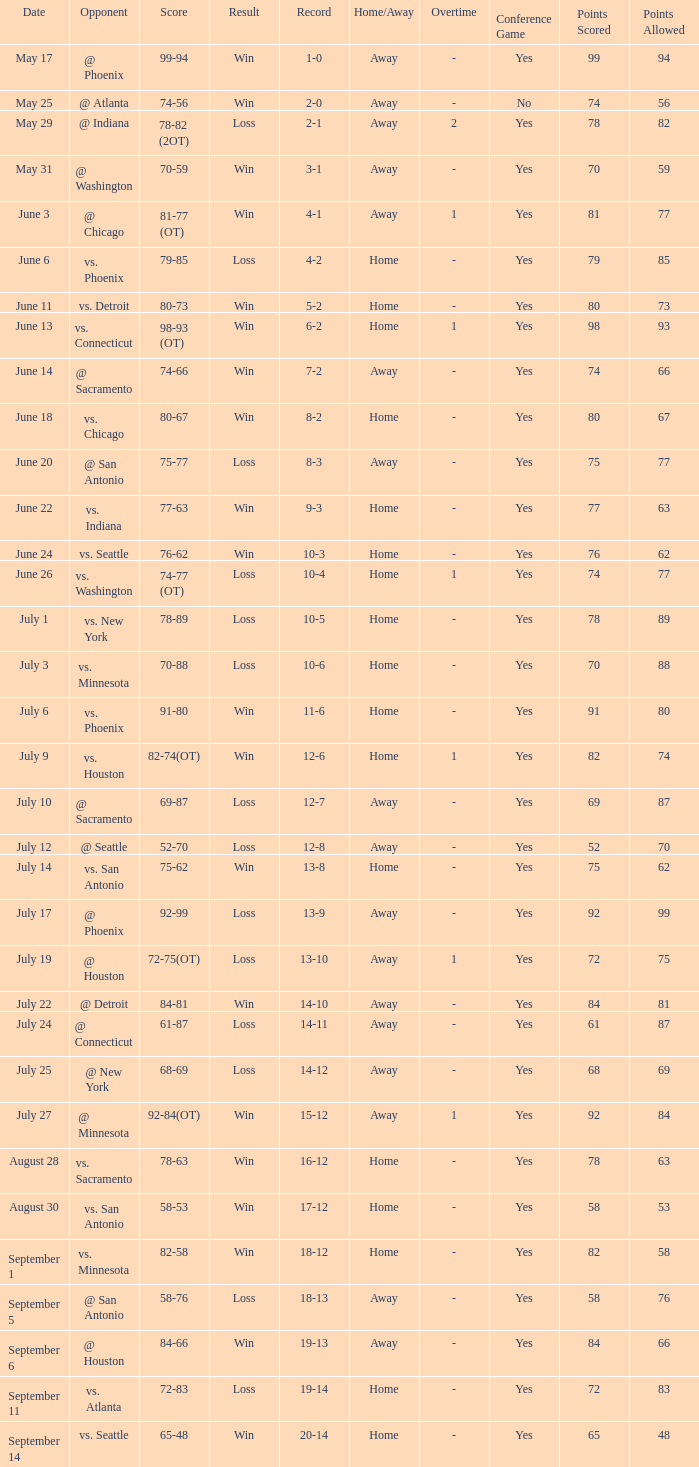What is the Score of the game @ San Antonio on June 20? 75-77. 